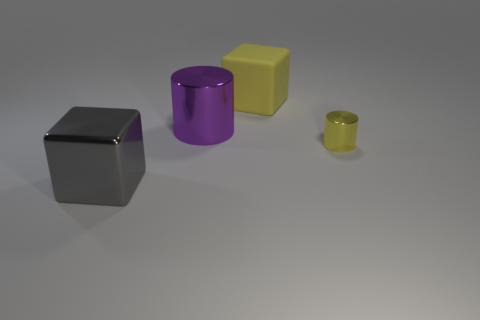Is there any other thing that is the same size as the yellow cylinder?
Keep it short and to the point. No. There is a thing that is behind the metallic cube and to the left of the big rubber block; what size is it?
Offer a terse response. Large. Does the yellow shiny object have the same shape as the big metal thing that is on the right side of the big gray shiny block?
Your response must be concise. Yes. The other rubber thing that is the same shape as the big gray object is what size?
Give a very brief answer. Large. Do the small shiny cylinder and the metallic cylinder that is to the left of the tiny cylinder have the same color?
Your answer should be compact. No. What number of other objects are there of the same size as the gray shiny thing?
Your answer should be very brief. 2. What is the shape of the big metallic thing behind the cube in front of the big metal thing that is on the right side of the large shiny cube?
Offer a very short reply. Cylinder. There is a purple shiny object; is it the same size as the cylinder in front of the big purple shiny object?
Offer a terse response. No. There is a object that is to the right of the big metallic cylinder and behind the tiny cylinder; what is its color?
Provide a succinct answer. Yellow. There is a big thing that is in front of the small yellow metal object; is it the same color as the big metal object that is to the right of the large gray cube?
Your response must be concise. No. 